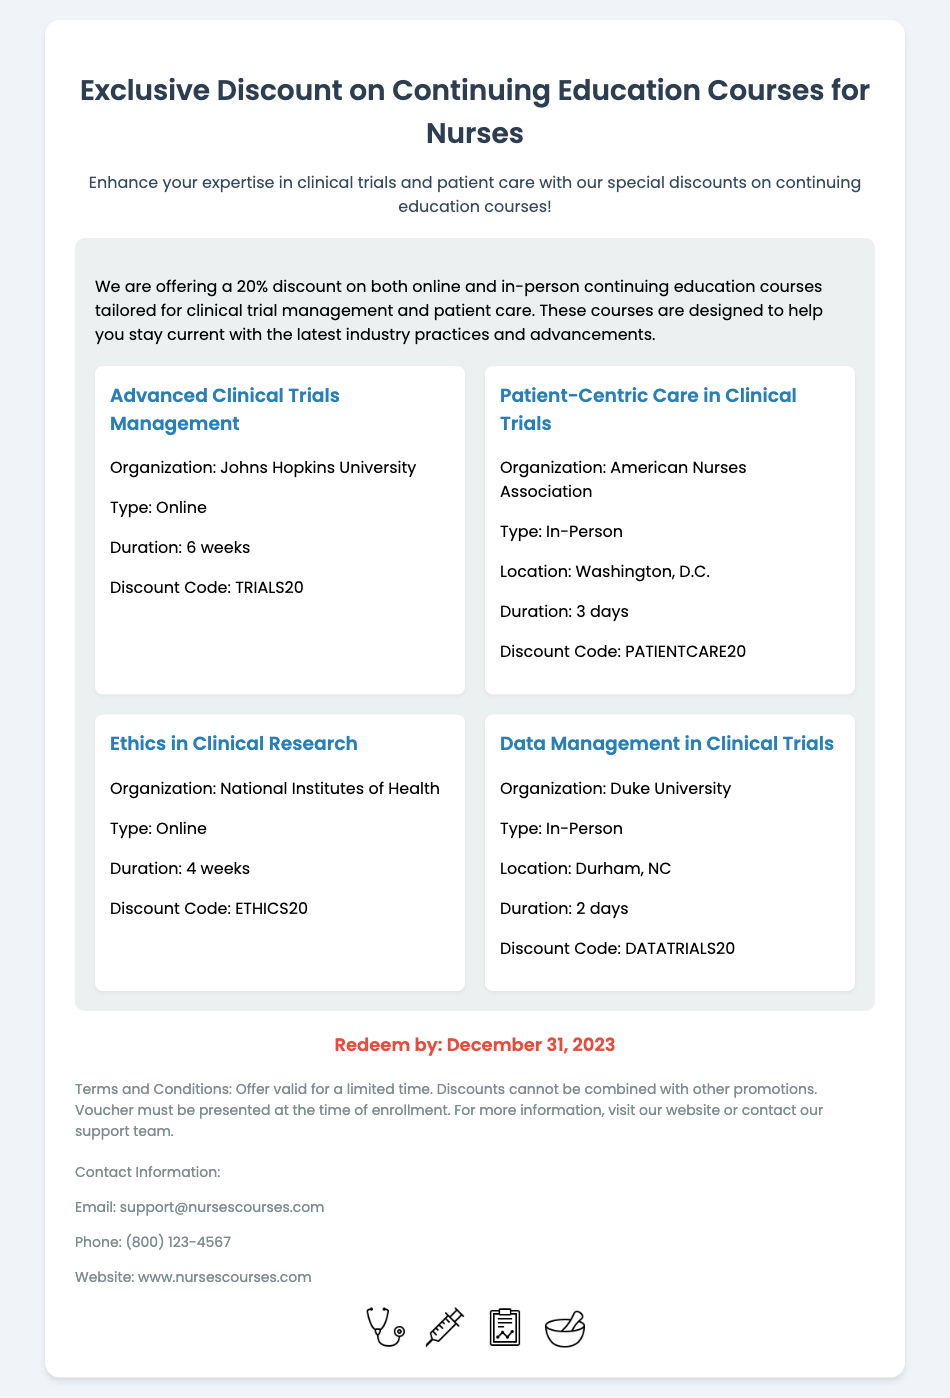What is the discount percentage? The document states the discount offered for courses is 20%.
Answer: 20% What is the redeem-by date? The document clearly mentions the date by which the voucher must be redeemed as December 31, 2023.
Answer: December 31, 2023 How many courses are listed in the document? The document provides details on four different courses available for nurses.
Answer: Four Where is the "Patient-Centric Care in Clinical Trials" course held? The document specifies that this course is an in-person event located in Washington, D.C.
Answer: Washington, D.C What is the duration of the "Advanced Clinical Trials Management" course? According to the document, this particular course lasts for 6 weeks.
Answer: 6 weeks What is the contact email provided in the document? The document includes a contact email for support, which is support@nursescourses.com.
Answer: support@nursescourses.com Which organization offers the "Ethics in Clinical Research" course? The document mentions that this course is offered by the National Institutes of Health.
Answer: National Institutes of Health What type of courses does the voucher apply to? The document indicates that the voucher applies to both online and in-person continuing education courses.
Answer: Online and in-person 